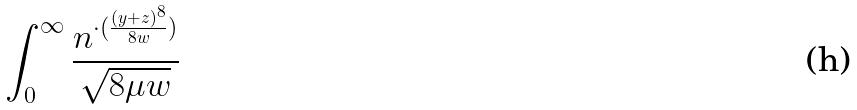Convert formula to latex. <formula><loc_0><loc_0><loc_500><loc_500>\int _ { 0 } ^ { \infty } \frac { n ^ { \cdot ( \frac { ( y + z ) ^ { 8 } } { 8 w } ) } } { \sqrt { 8 \mu w } }</formula> 